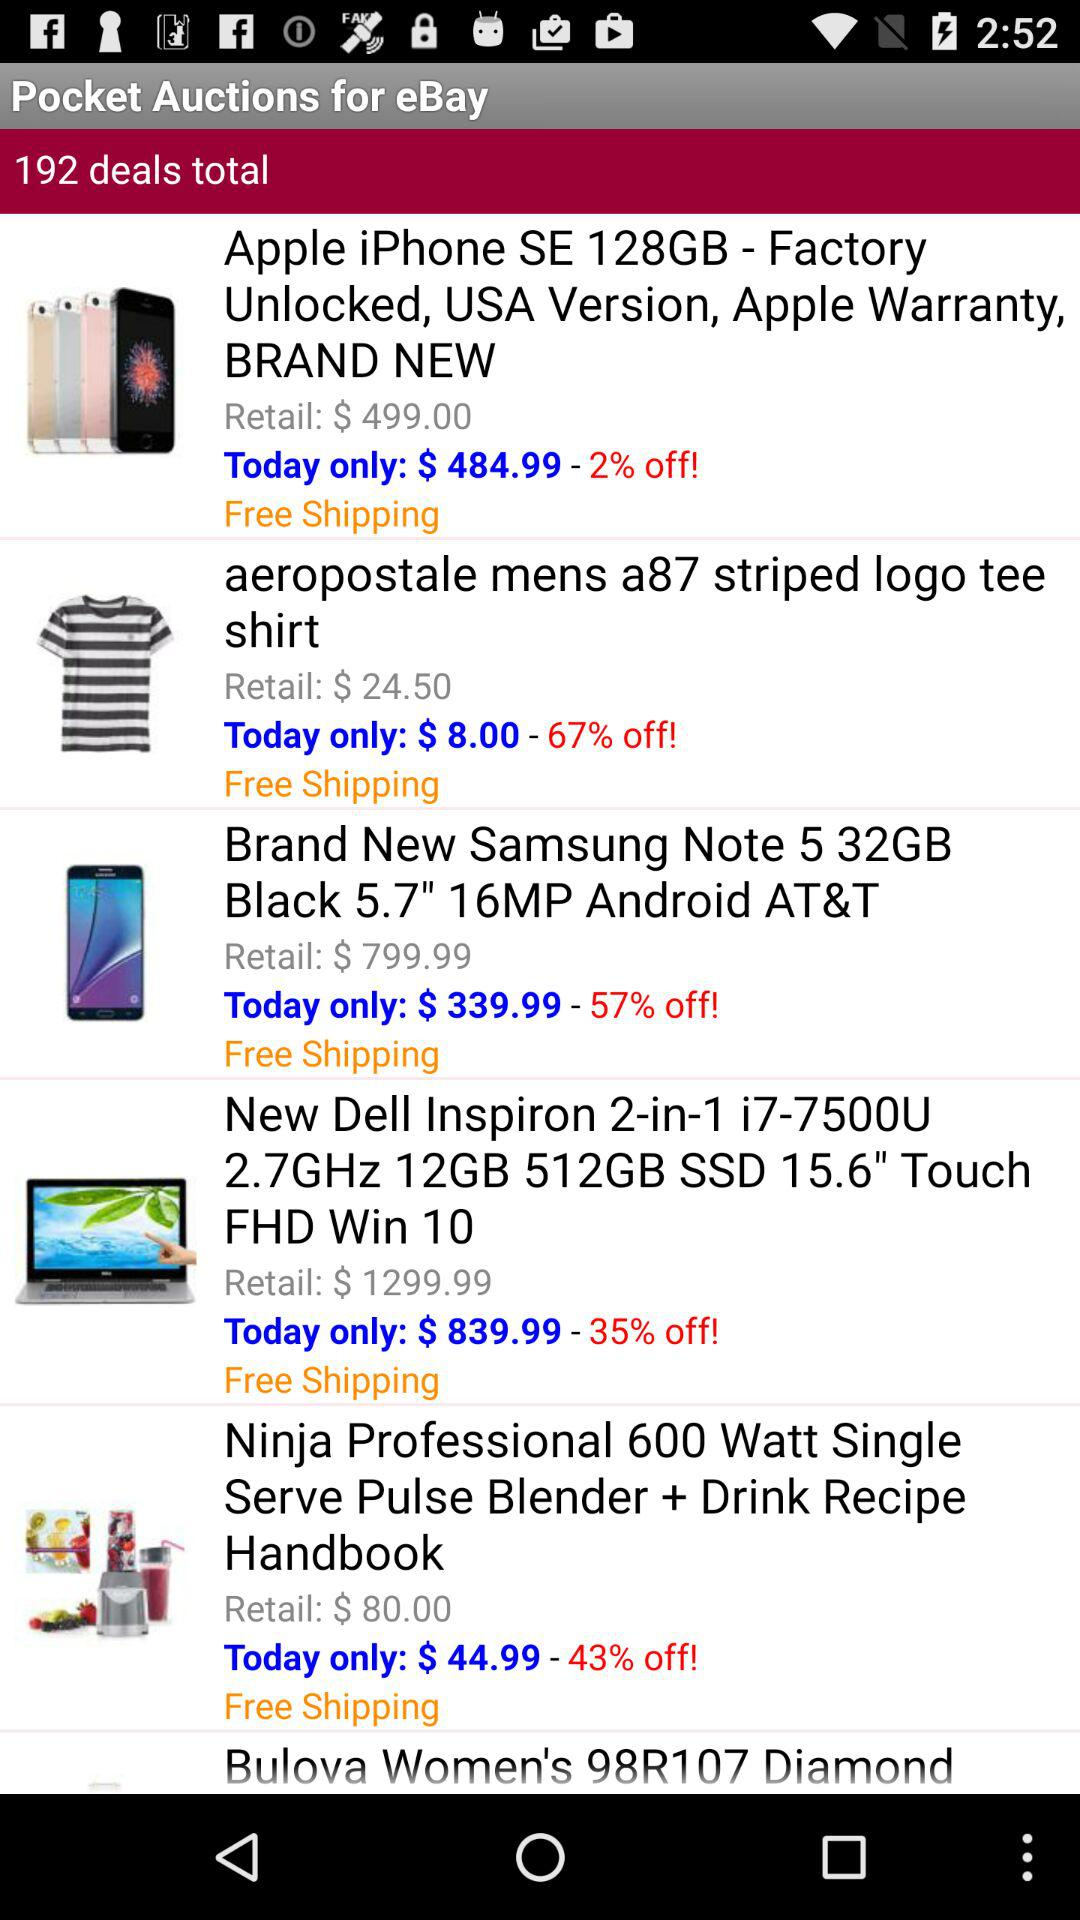What is the retail price of the "Brand New Samsung Note 5 32GB"? The retail price is $799.99. 